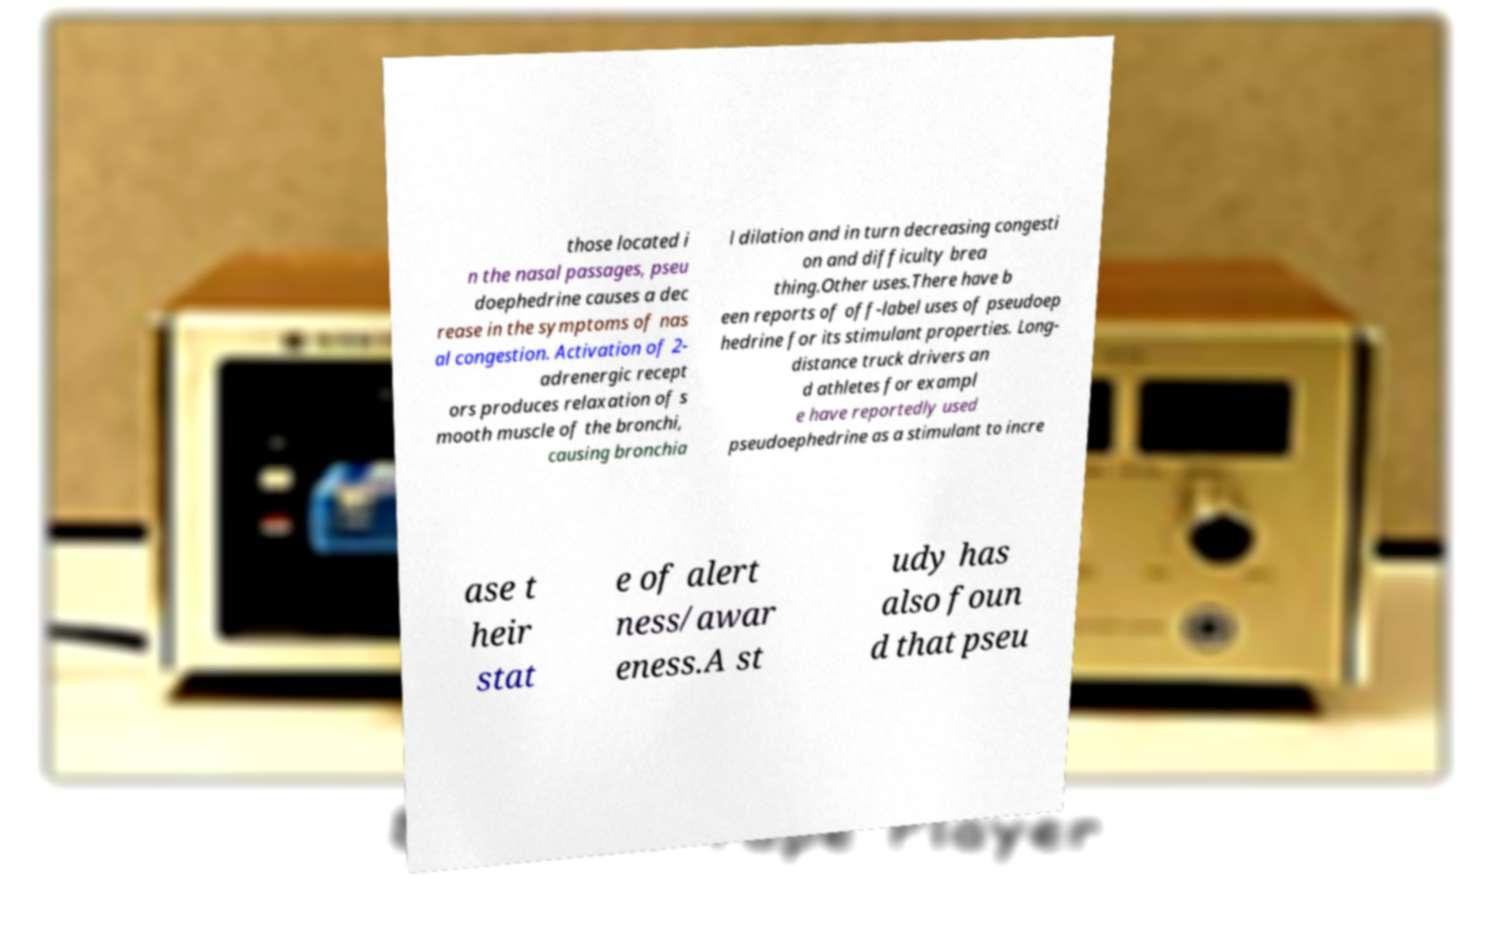Could you assist in decoding the text presented in this image and type it out clearly? those located i n the nasal passages, pseu doephedrine causes a dec rease in the symptoms of nas al congestion. Activation of 2- adrenergic recept ors produces relaxation of s mooth muscle of the bronchi, causing bronchia l dilation and in turn decreasing congesti on and difficulty brea thing.Other uses.There have b een reports of off-label uses of pseudoep hedrine for its stimulant properties. Long- distance truck drivers an d athletes for exampl e have reportedly used pseudoephedrine as a stimulant to incre ase t heir stat e of alert ness/awar eness.A st udy has also foun d that pseu 